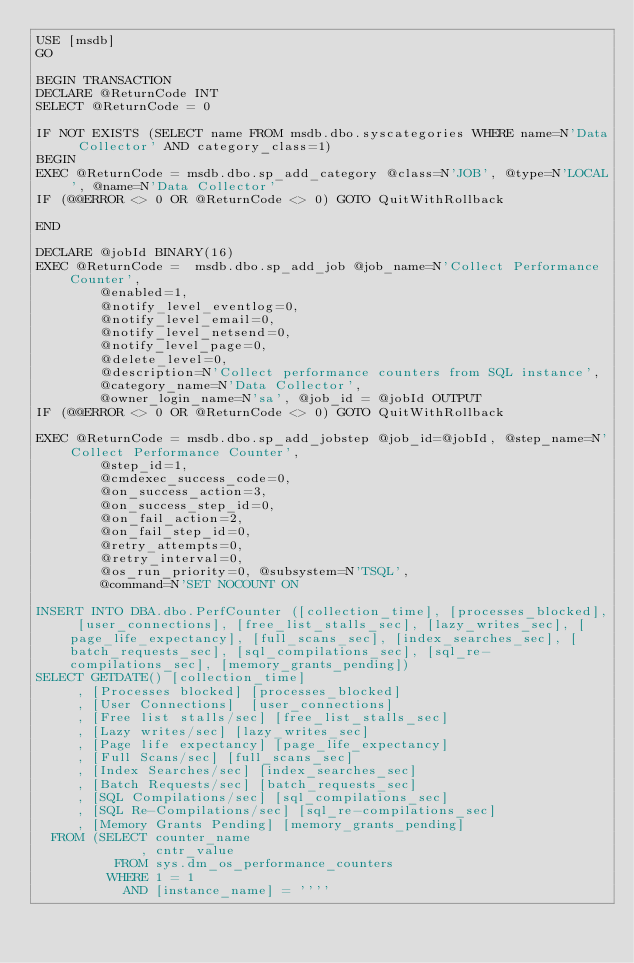Convert code to text. <code><loc_0><loc_0><loc_500><loc_500><_SQL_>USE [msdb]
GO

BEGIN TRANSACTION
DECLARE @ReturnCode INT
SELECT @ReturnCode = 0

IF NOT EXISTS (SELECT name FROM msdb.dbo.syscategories WHERE name=N'Data Collector' AND category_class=1)
BEGIN
EXEC @ReturnCode = msdb.dbo.sp_add_category @class=N'JOB', @type=N'LOCAL', @name=N'Data Collector'
IF (@@ERROR <> 0 OR @ReturnCode <> 0) GOTO QuitWithRollback

END

DECLARE @jobId BINARY(16)
EXEC @ReturnCode =  msdb.dbo.sp_add_job @job_name=N'Collect Performance Counter', 
		@enabled=1, 
		@notify_level_eventlog=0, 
		@notify_level_email=0, 
		@notify_level_netsend=0, 
		@notify_level_page=0, 
		@delete_level=0, 
		@description=N'Collect performance counters from SQL instance', 
		@category_name=N'Data Collector', 
		@owner_login_name=N'sa', @job_id = @jobId OUTPUT
IF (@@ERROR <> 0 OR @ReturnCode <> 0) GOTO QuitWithRollback

EXEC @ReturnCode = msdb.dbo.sp_add_jobstep @job_id=@jobId, @step_name=N'Collect Performance Counter', 
		@step_id=1, 
		@cmdexec_success_code=0, 
		@on_success_action=3, 
		@on_success_step_id=0, 
		@on_fail_action=2, 
		@on_fail_step_id=0, 
		@retry_attempts=0, 
		@retry_interval=0, 
		@os_run_priority=0, @subsystem=N'TSQL', 
		@command=N'SET NOCOUNT ON

INSERT INTO DBA.dbo.PerfCounter ([collection_time], [processes_blocked], [user_connections], [free_list_stalls_sec], [lazy_writes_sec], [page_life_expectancy], [full_scans_sec], [index_searches_sec], [batch_requests_sec], [sql_compilations_sec], [sql_re-compilations_sec], [memory_grants_pending])
SELECT GETDATE() [collection_time]
     , [Processes blocked] [processes_blocked]
     , [User Connections]  [user_connections]
     , [Free list stalls/sec] [free_list_stalls_sec]
     , [Lazy writes/sec] [lazy_writes_sec]
     , [Page life expectancy] [page_life_expectancy]
     , [Full Scans/sec] [full_scans_sec]
     , [Index Searches/sec] [index_searches_sec]
     , [Batch Requests/sec] [batch_requests_sec]
     , [SQL Compilations/sec] [sql_compilations_sec]
     , [SQL Re-Compilations/sec] [sql_re-compilations_sec]
     , [Memory Grants Pending] [memory_grants_pending]
  FROM (SELECT counter_name
             , cntr_value
          FROM sys.dm_os_performance_counters
         WHERE 1 = 1
           AND [instance_name] = ''''</code> 